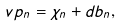Convert formula to latex. <formula><loc_0><loc_0><loc_500><loc_500>\ v p _ { n } = \chi _ { n } + d b _ { n } ,</formula> 